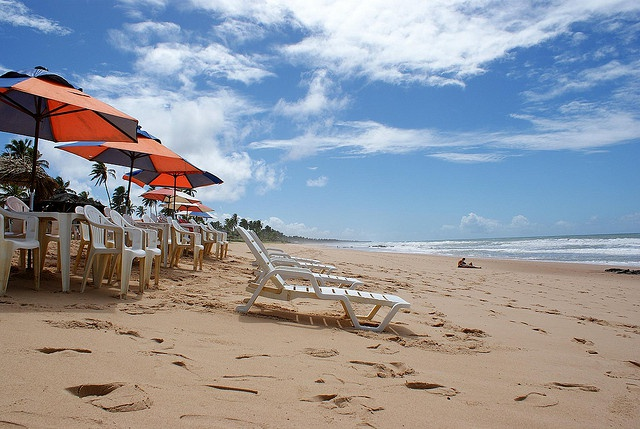Describe the objects in this image and their specific colors. I can see umbrella in lightblue, black, salmon, and brown tones, chair in lightblue, gray, darkgray, and lightgray tones, umbrella in lightblue, black, salmon, brown, and red tones, chair in lightblue, darkgray, gray, and maroon tones, and chair in lightblue, gray, black, and maroon tones in this image. 